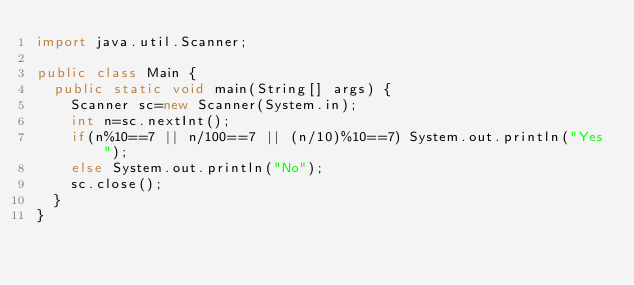Convert code to text. <code><loc_0><loc_0><loc_500><loc_500><_Java_>import java.util.Scanner;

public class Main {
	public static void main(String[] args) {
		Scanner sc=new Scanner(System.in);
		int n=sc.nextInt();
		if(n%10==7 || n/100==7 || (n/10)%10==7) System.out.println("Yes");
		else System.out.println("No");
		sc.close();
	}
}</code> 